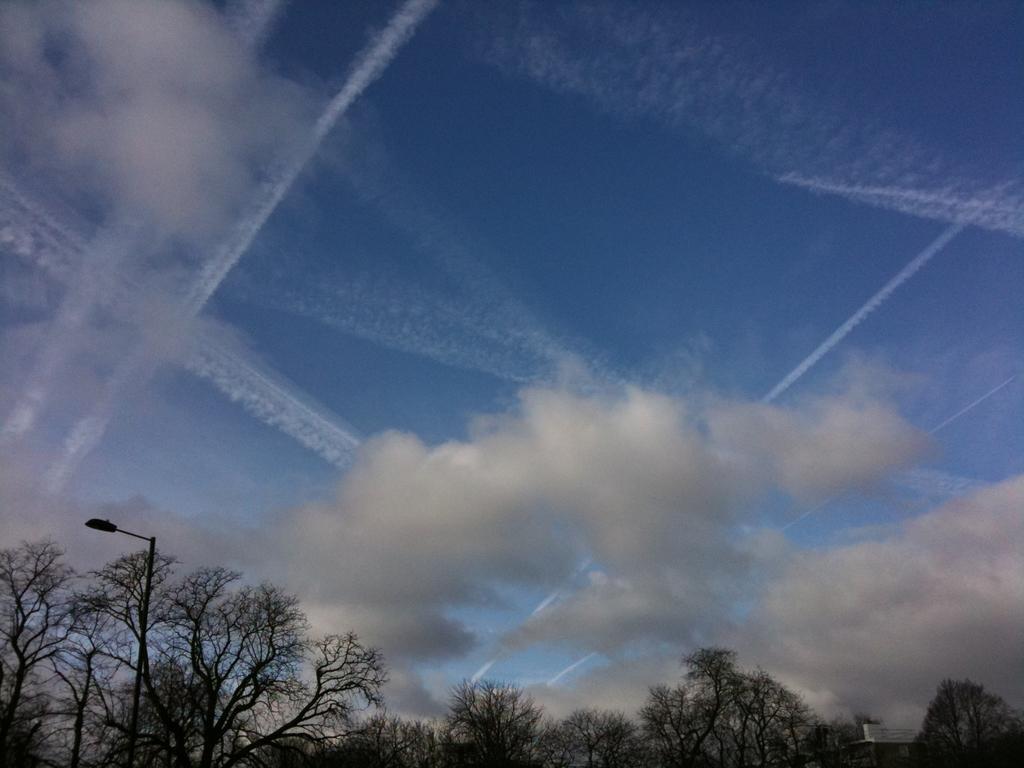Please provide a concise description of this image. In this image I can see the many trees and the light pole. In the background I can see the clouds and the blue sky. 